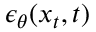Convert formula to latex. <formula><loc_0><loc_0><loc_500><loc_500>\epsilon _ { \theta } ( x _ { t } , t )</formula> 